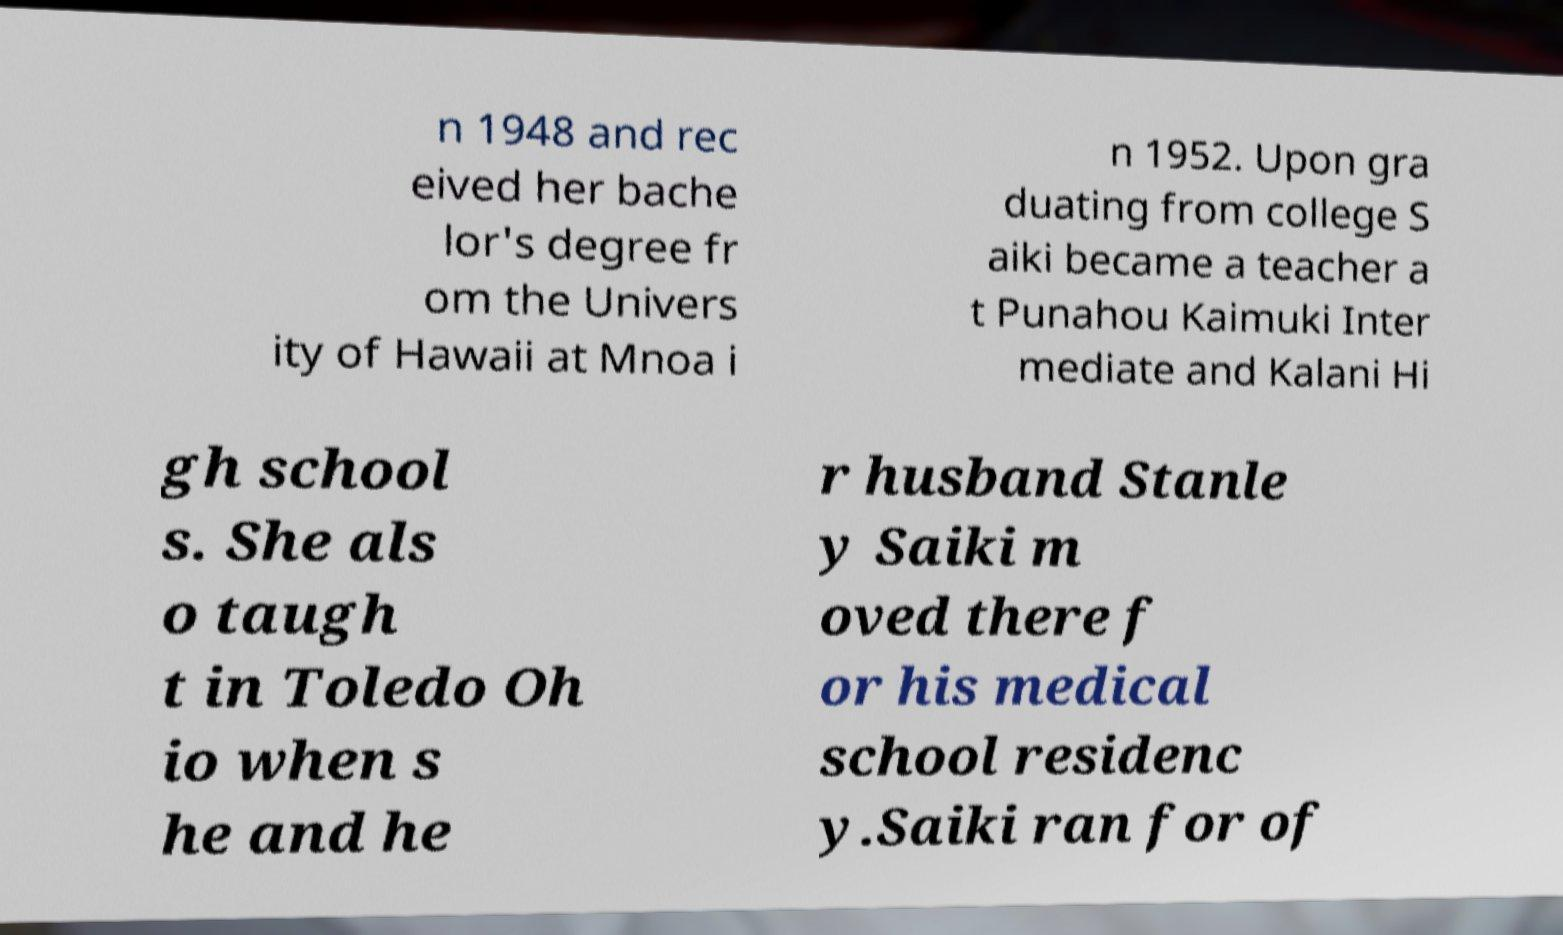There's text embedded in this image that I need extracted. Can you transcribe it verbatim? n 1948 and rec eived her bache lor's degree fr om the Univers ity of Hawaii at Mnoa i n 1952. Upon gra duating from college S aiki became a teacher a t Punahou Kaimuki Inter mediate and Kalani Hi gh school s. She als o taugh t in Toledo Oh io when s he and he r husband Stanle y Saiki m oved there f or his medical school residenc y.Saiki ran for of 